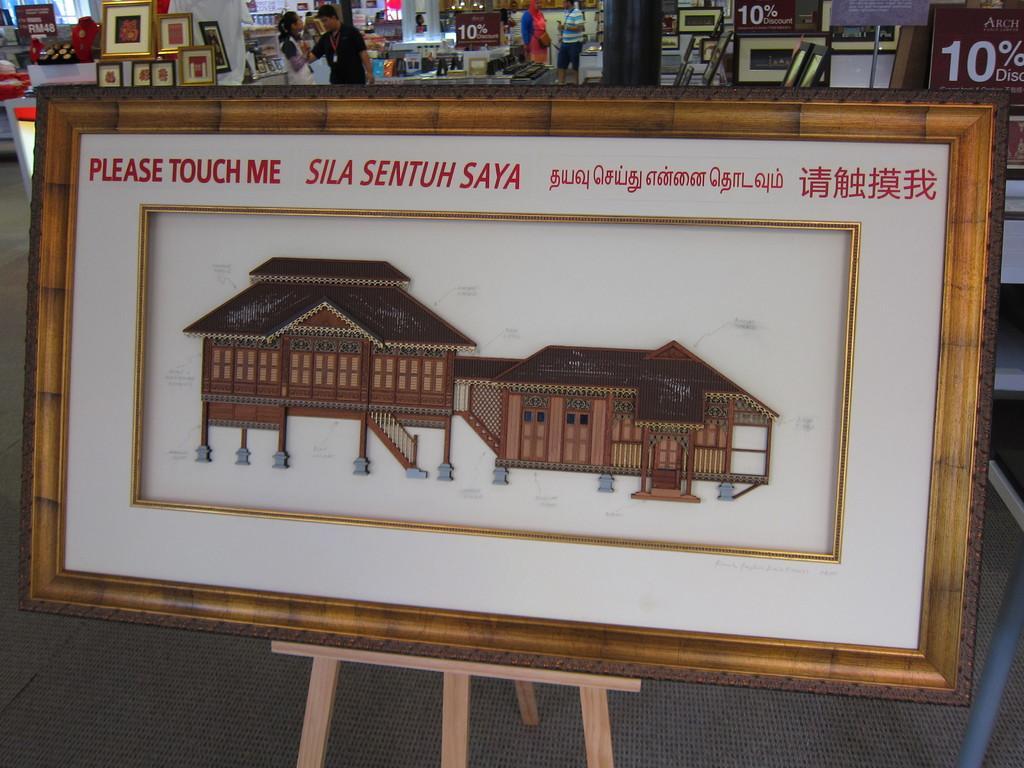Could you give a brief overview of what you see in this image? In the center of the picture there is a frame on the stand. In the frame there is a building and there is text. In the background there are people, frames, stands and other objects. 